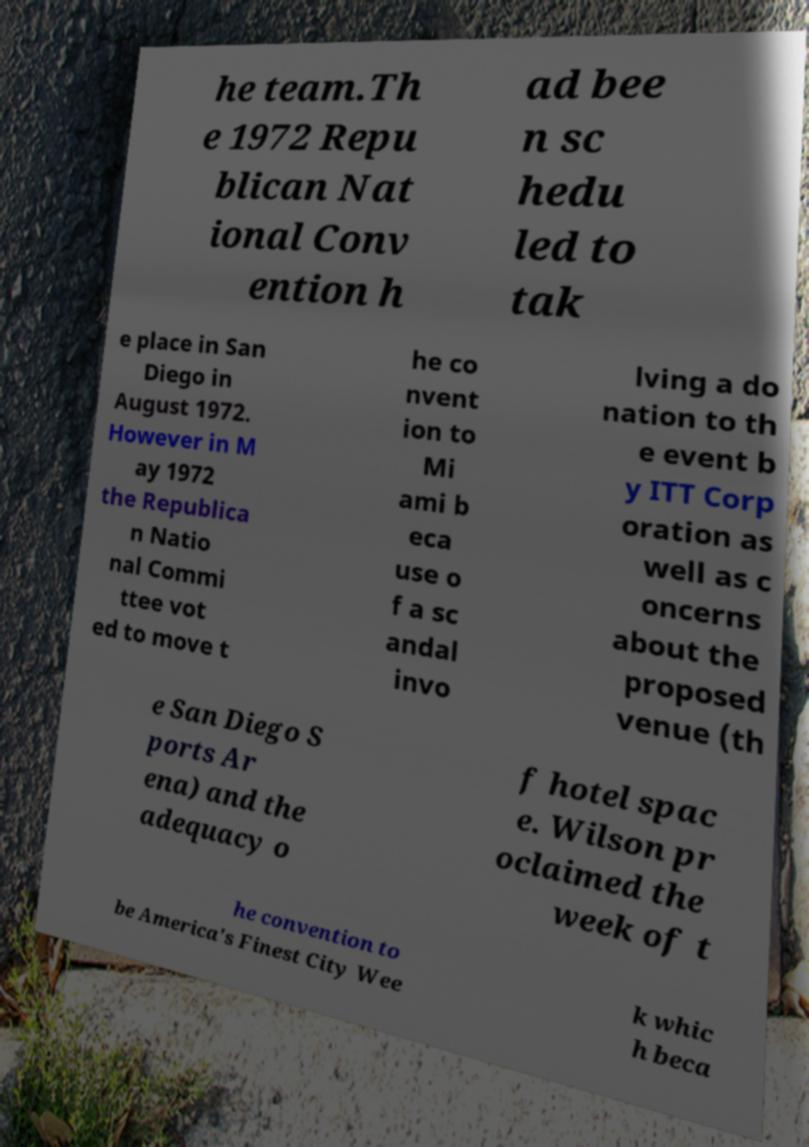Can you accurately transcribe the text from the provided image for me? he team.Th e 1972 Repu blican Nat ional Conv ention h ad bee n sc hedu led to tak e place in San Diego in August 1972. However in M ay 1972 the Republica n Natio nal Commi ttee vot ed to move t he co nvent ion to Mi ami b eca use o f a sc andal invo lving a do nation to th e event b y ITT Corp oration as well as c oncerns about the proposed venue (th e San Diego S ports Ar ena) and the adequacy o f hotel spac e. Wilson pr oclaimed the week of t he convention to be America's Finest City Wee k whic h beca 